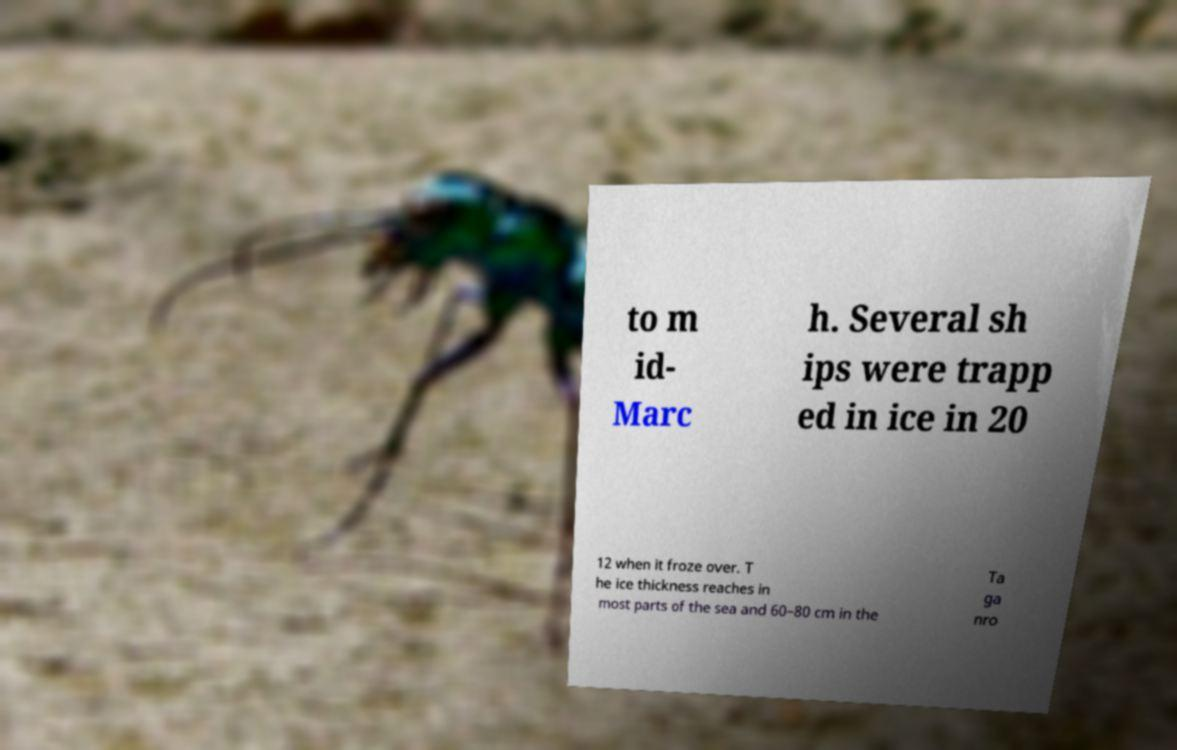There's text embedded in this image that I need extracted. Can you transcribe it verbatim? to m id- Marc h. Several sh ips were trapp ed in ice in 20 12 when it froze over. T he ice thickness reaches in most parts of the sea and 60–80 cm in the Ta ga nro 